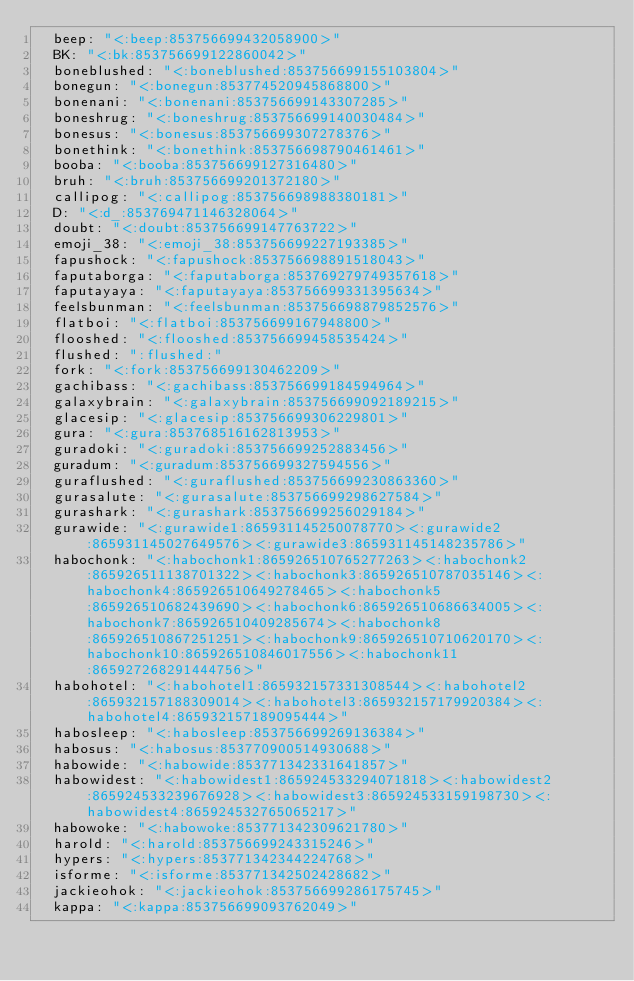Convert code to text. <code><loc_0><loc_0><loc_500><loc_500><_YAML_>  beep: "<:beep:853756699432058900>"
  BK: "<:bk:853756699122860042>"
  boneblushed: "<:boneblushed:853756699155103804>"
  bonegun: "<:bonegun:853774520945868800>"
  bonenani: "<:bonenani:853756699143307285>"
  boneshrug: "<:boneshrug:853756699140030484>"
  bonesus: "<:bonesus:853756699307278376>"
  bonethink: "<:bonethink:853756698790461461>"
  booba: "<:booba:853756699127316480>"
  bruh: "<:bruh:853756699201372180>"
  callipog: "<:callipog:853756698988380181>"
  D: "<:d_:853769471146328064>"
  doubt: "<:doubt:853756699147763722>"
  emoji_38: "<:emoji_38:853756699227193385>"
  fapushock: "<:fapushock:853756698891518043>"
  faputaborga: "<:faputaborga:853769279749357618>"
  faputayaya: "<:faputayaya:853756699331395634>"
  feelsbunman: "<:feelsbunman:853756698879852576>"
  flatboi: "<:flatboi:853756699167948800>"
  flooshed: "<:flooshed:853756699458535424>"
  flushed: ":flushed:"
  fork: "<:fork:853756699130462209>"
  gachibass: "<:gachibass:853756699184594964>"
  galaxybrain: "<:galaxybrain:853756699092189215>"
  glacesip: "<:glacesip:853756699306229801>"
  gura: "<:gura:853768516162813953>"
  guradoki: "<:guradoki:853756699252883456>"
  guradum: "<:guradum:853756699327594556>"
  guraflushed: "<:guraflushed:853756699230863360>"
  gurasalute: "<:gurasalute:853756699298627584>"
  gurashark: "<:gurashark:853756699256029184>"
  gurawide: "<:gurawide1:865931145250078770><:gurawide2:865931145027649576><:gurawide3:865931145148235786>"
  habochonk: "<:habochonk1:865926510765277263><:habochonk2:865926511138701322><:habochonk3:865926510787035146><:habochonk4:865926510649278465><:habochonk5:865926510682439690><:habochonk6:865926510686634005><:habochonk7:865926510409285674><:habochonk8:865926510867251251><:habochonk9:865926510710620170><:habochonk10:865926510846017556><:habochonk11:865927268291444756>"
  habohotel: "<:habohotel1:865932157331308544><:habohotel2:865932157188309014><:habohotel3:865932157179920384><:habohotel4:865932157189095444>"
  habosleep: "<:habosleep:853756699269136384>"
  habosus: "<:habosus:853770900514930688>"
  habowide: "<:habowide:853771342331641857>"
  habowidest: "<:habowidest1:865924533294071818><:habowidest2:865924533239676928><:habowidest3:865924533159198730><:habowidest4:865924532765065217>"
  habowoke: "<:habowoke:853771342309621780>"
  harold: "<:harold:853756699243315246>"
  hypers: "<:hypers:853771342344224768>"
  isforme: "<:isforme:853771342502428682>"
  jackieohok: "<:jackieohok:853756699286175745>"
  kappa: "<:kappa:853756699093762049>"</code> 